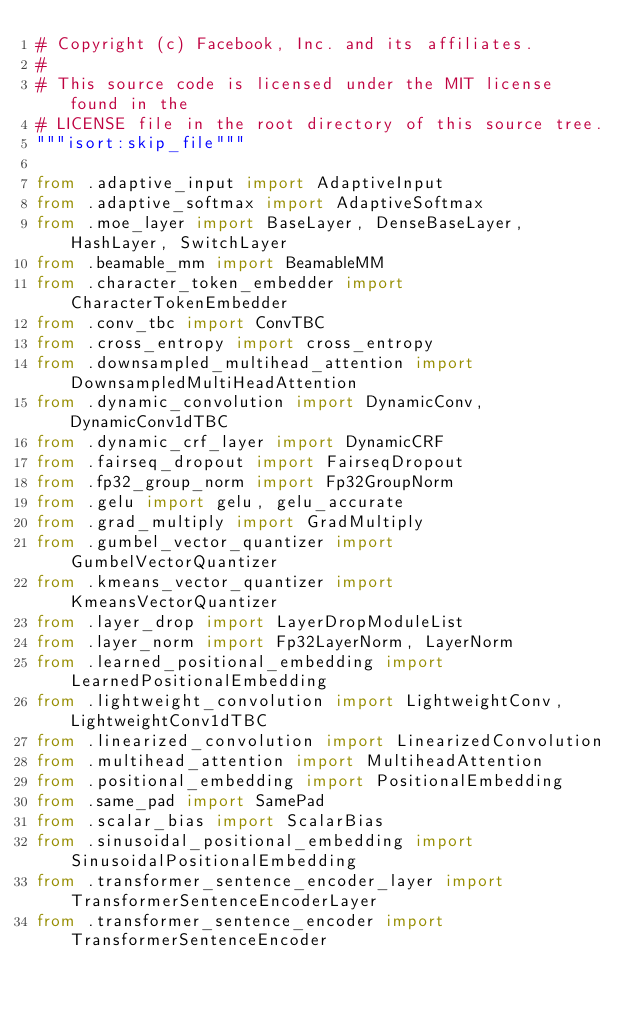<code> <loc_0><loc_0><loc_500><loc_500><_Python_># Copyright (c) Facebook, Inc. and its affiliates.
#
# This source code is licensed under the MIT license found in the
# LICENSE file in the root directory of this source tree.
"""isort:skip_file"""

from .adaptive_input import AdaptiveInput
from .adaptive_softmax import AdaptiveSoftmax
from .moe_layer import BaseLayer, DenseBaseLayer, HashLayer, SwitchLayer
from .beamable_mm import BeamableMM
from .character_token_embedder import CharacterTokenEmbedder
from .conv_tbc import ConvTBC
from .cross_entropy import cross_entropy
from .downsampled_multihead_attention import DownsampledMultiHeadAttention
from .dynamic_convolution import DynamicConv, DynamicConv1dTBC
from .dynamic_crf_layer import DynamicCRF
from .fairseq_dropout import FairseqDropout
from .fp32_group_norm import Fp32GroupNorm
from .gelu import gelu, gelu_accurate
from .grad_multiply import GradMultiply
from .gumbel_vector_quantizer import GumbelVectorQuantizer
from .kmeans_vector_quantizer import KmeansVectorQuantizer
from .layer_drop import LayerDropModuleList
from .layer_norm import Fp32LayerNorm, LayerNorm
from .learned_positional_embedding import LearnedPositionalEmbedding
from .lightweight_convolution import LightweightConv, LightweightConv1dTBC
from .linearized_convolution import LinearizedConvolution
from .multihead_attention import MultiheadAttention
from .positional_embedding import PositionalEmbedding
from .same_pad import SamePad
from .scalar_bias import ScalarBias
from .sinusoidal_positional_embedding import SinusoidalPositionalEmbedding
from .transformer_sentence_encoder_layer import TransformerSentenceEncoderLayer
from .transformer_sentence_encoder import TransformerSentenceEncoder</code> 